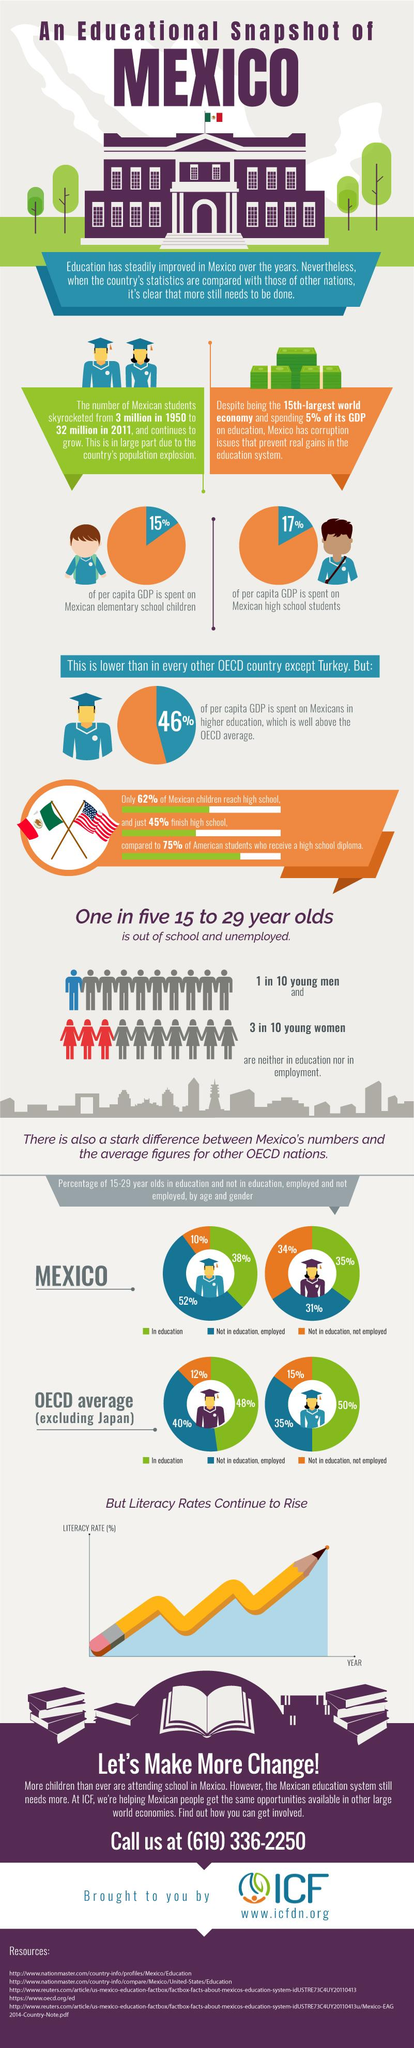Identify some key points in this picture. According to recent data, the per capita GDP spent on higher education for Mexicans is higher than that of any other country, including Turkey. In Mexico, it is estimated that approximately 65% of females are not in education, but either employed or not employed. In Mexico, approximately 62% of males are not in education, but either employed or not employed. Mexico has the second-lowest per-capita spending on higher education among all OECD countries, according to recent data. From 1950 to 2011, the number of students in the world increased by approximately 2.9 billion. 